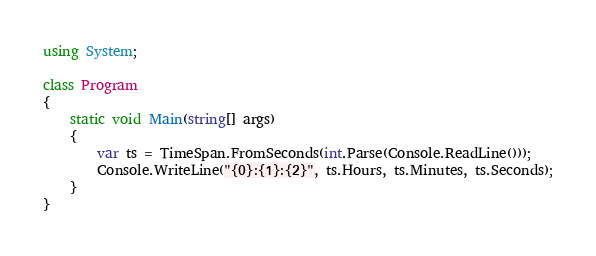<code> <loc_0><loc_0><loc_500><loc_500><_C#_>using System;
   
class Program
{
    static void Main(string[] args)
    {
        var ts = TimeSpan.FromSeconds(int.Parse(Console.ReadLine()));
        Console.WriteLine("{0}:{1}:{2}", ts.Hours, ts.Minutes, ts.Seconds);
    }
}</code> 